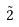Convert formula to latex. <formula><loc_0><loc_0><loc_500><loc_500>\tilde { 2 }</formula> 